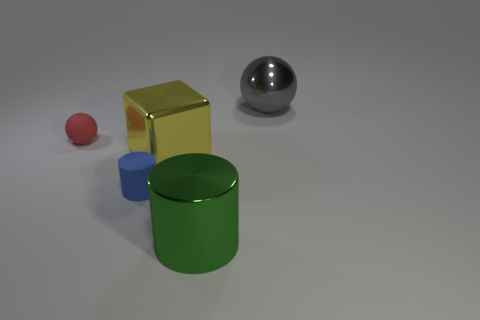There is a thing that is to the right of the blue cylinder and on the left side of the green metallic thing; how big is it?
Keep it short and to the point. Large. What is the material of the big object that is behind the large metallic cube?
Make the answer very short. Metal. What is the material of the red thing?
Keep it short and to the point. Rubber. There is a metal object behind the ball that is left of the shiny object that is behind the tiny matte ball; what is its shape?
Keep it short and to the point. Sphere. Is the number of large metallic objects behind the large yellow object greater than the number of blue matte cubes?
Provide a short and direct response. Yes. Is the shape of the tiny red matte object the same as the thing behind the red sphere?
Give a very brief answer. Yes. What number of cylinders are behind the ball in front of the large object that is behind the red ball?
Provide a short and direct response. 0. There is a metallic cylinder that is the same size as the gray metallic ball; what is its color?
Your answer should be very brief. Green. There is a sphere that is in front of the big metal thing behind the red ball; what is its size?
Offer a terse response. Small. What number of other objects are the same size as the green shiny object?
Give a very brief answer. 2. 